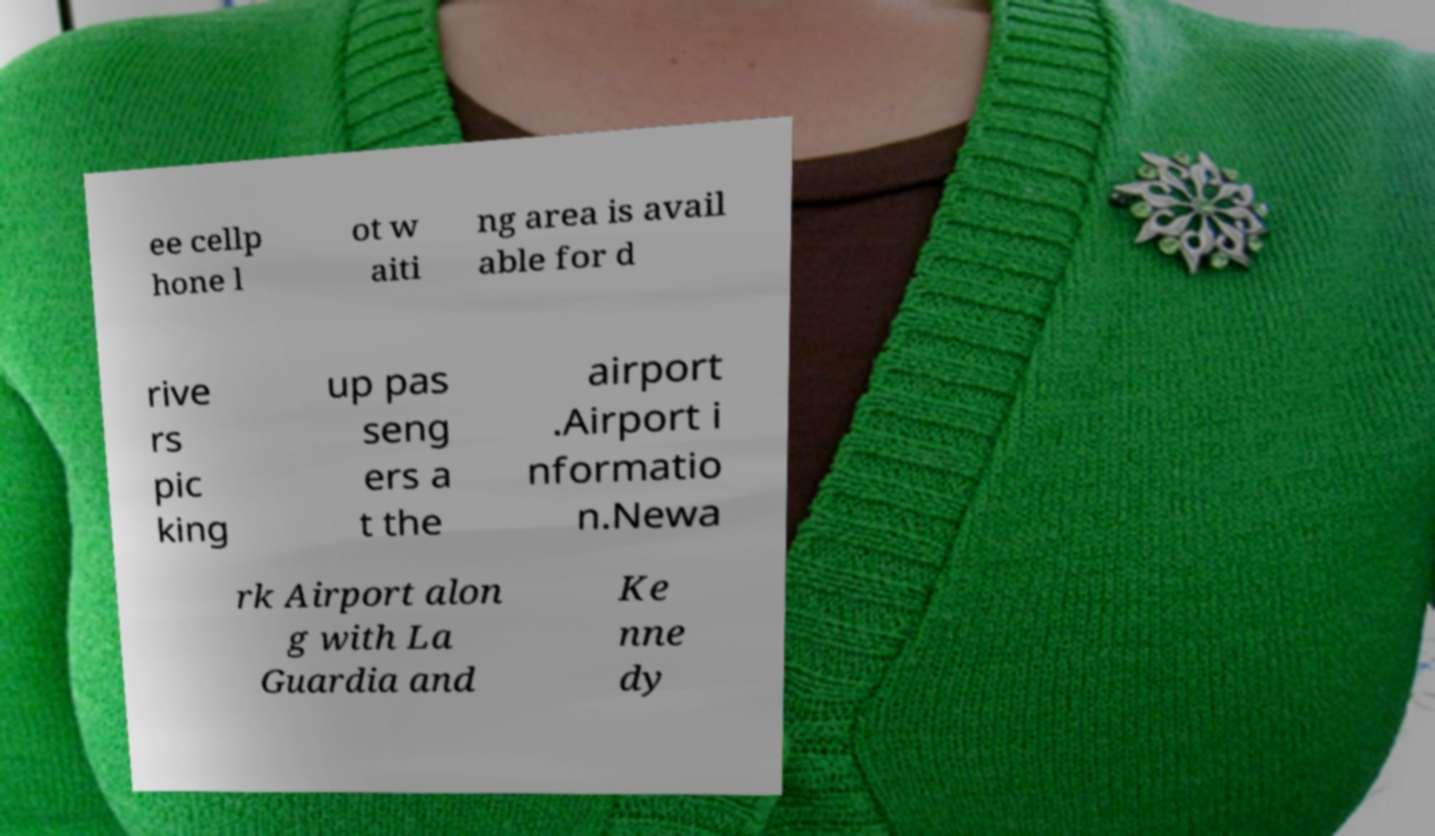For documentation purposes, I need the text within this image transcribed. Could you provide that? ee cellp hone l ot w aiti ng area is avail able for d rive rs pic king up pas seng ers a t the airport .Airport i nformatio n.Newa rk Airport alon g with La Guardia and Ke nne dy 